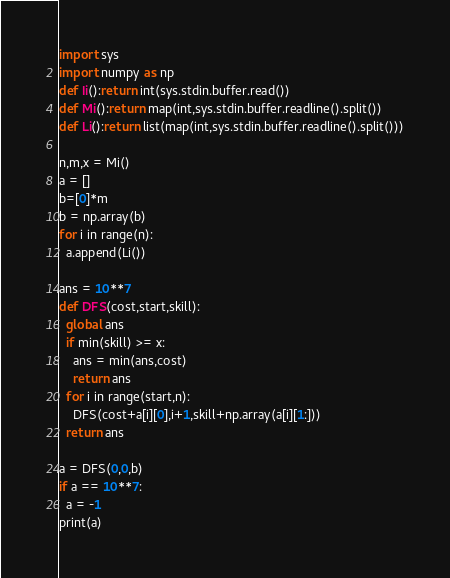<code> <loc_0><loc_0><loc_500><loc_500><_Python_>import sys
import numpy as np
def Ii():return int(sys.stdin.buffer.read())
def Mi():return map(int,sys.stdin.buffer.readline().split())
def Li():return list(map(int,sys.stdin.buffer.readline().split()))
  
n,m,x = Mi()
a = []
b=[0]*m
b = np.array(b)
for i in range(n):
  a.append(Li())
  
ans = 10**7
def DFS(cost,start,skill):
  global ans
  if min(skill) >= x:
    ans = min(ans,cost)
    return ans
  for i in range(start,n):
    DFS(cost+a[i][0],i+1,skill+np.array(a[i][1:]))
  return ans

a = DFS(0,0,b)
if a == 10**7:
  a = -1
print(a)</code> 